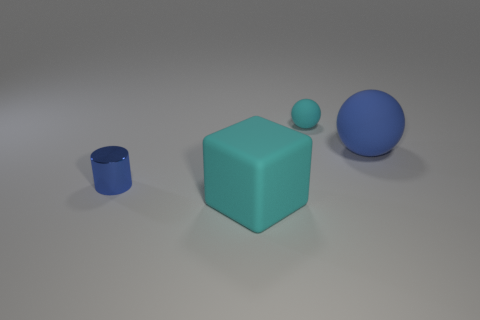Is there anything else that is the same shape as the tiny blue object?
Give a very brief answer. No. Is there any other thing that has the same material as the cylinder?
Keep it short and to the point. No. How many balls have the same size as the cylinder?
Make the answer very short. 1. What number of objects are rubber things that are left of the small cyan matte ball or big matte things in front of the blue shiny cylinder?
Your answer should be compact. 1. Is the shape of the small blue thing the same as the small object right of the tiny blue shiny cylinder?
Provide a succinct answer. No. There is a matte object behind the blue object to the right of the matte thing that is on the left side of the tiny sphere; what is its shape?
Provide a short and direct response. Sphere. How many other things are made of the same material as the large ball?
Provide a succinct answer. 2. How many objects are small matte things right of the tiny metallic thing or big gray cylinders?
Ensure brevity in your answer.  1. What is the shape of the tiny object that is in front of the big object to the right of the cyan block?
Keep it short and to the point. Cylinder. Does the big matte thing behind the blue shiny thing have the same shape as the tiny matte object?
Make the answer very short. Yes. 